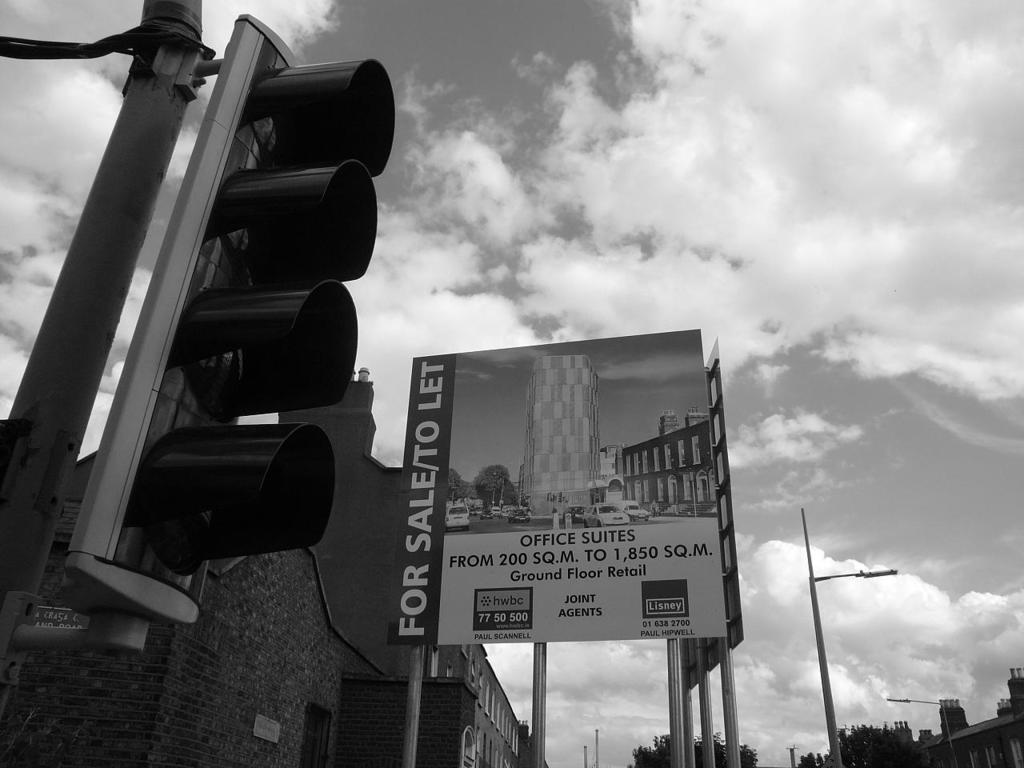How would you summarize this image in a sentence or two? In this image I can see a traffic signal, background I can see a board attached to the pole, few buildings, trees, light poles and sky, and the image is in black and white. 